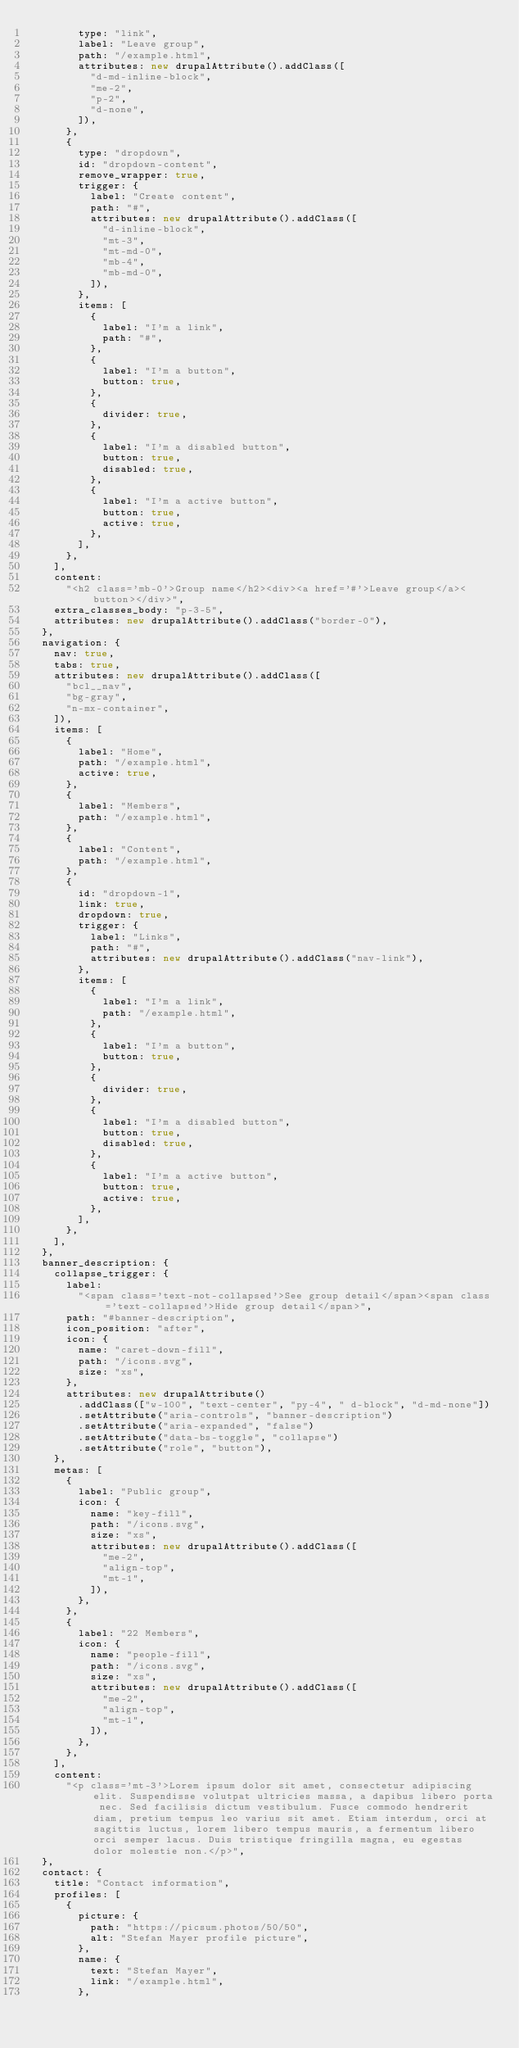Convert code to text. <code><loc_0><loc_0><loc_500><loc_500><_JavaScript_>        type: "link",
        label: "Leave group",
        path: "/example.html",
        attributes: new drupalAttribute().addClass([
          "d-md-inline-block",
          "me-2",
          "p-2",
          "d-none",
        ]),
      },
      {
        type: "dropdown",
        id: "dropdown-content",
        remove_wrapper: true,
        trigger: {
          label: "Create content",
          path: "#",
          attributes: new drupalAttribute().addClass([
            "d-inline-block",
            "mt-3",
            "mt-md-0",
            "mb-4",
            "mb-md-0",
          ]),
        },
        items: [
          {
            label: "I'm a link",
            path: "#",
          },
          {
            label: "I'm a button",
            button: true,
          },
          {
            divider: true,
          },
          {
            label: "I'm a disabled button",
            button: true,
            disabled: true,
          },
          {
            label: "I'm a active button",
            button: true,
            active: true,
          },
        ],
      },
    ],
    content:
      "<h2 class='mb-0'>Group name</h2><div><a href='#'>Leave group</a><button></div>",
    extra_classes_body: "p-3-5",
    attributes: new drupalAttribute().addClass("border-0"),
  },
  navigation: {
    nav: true,
    tabs: true,
    attributes: new drupalAttribute().addClass([
      "bcl__nav",
      "bg-gray",
      "n-mx-container",
    ]),
    items: [
      {
        label: "Home",
        path: "/example.html",
        active: true,
      },
      {
        label: "Members",
        path: "/example.html",
      },
      {
        label: "Content",
        path: "/example.html",
      },
      {
        id: "dropdown-1",
        link: true,
        dropdown: true,
        trigger: {
          label: "Links",
          path: "#",
          attributes: new drupalAttribute().addClass("nav-link"),
        },
        items: [
          {
            label: "I'm a link",
            path: "/example.html",
          },
          {
            label: "I'm a button",
            button: true,
          },
          {
            divider: true,
          },
          {
            label: "I'm a disabled button",
            button: true,
            disabled: true,
          },
          {
            label: "I'm a active button",
            button: true,
            active: true,
          },
        ],
      },
    ],
  },
  banner_description: {
    collapse_trigger: {
      label:
        "<span class='text-not-collapsed'>See group detail</span><span class='text-collapsed'>Hide group detail</span>",
      path: "#banner-description",
      icon_position: "after",
      icon: {
        name: "caret-down-fill",
        path: "/icons.svg",
        size: "xs",
      },
      attributes: new drupalAttribute()
        .addClass(["w-100", "text-center", "py-4", " d-block", "d-md-none"])
        .setAttribute("aria-controls", "banner-description")
        .setAttribute("aria-expanded", "false")
        .setAttribute("data-bs-toggle", "collapse")
        .setAttribute("role", "button"),
    },
    metas: [
      {
        label: "Public group",
        icon: {
          name: "key-fill",
          path: "/icons.svg",
          size: "xs",
          attributes: new drupalAttribute().addClass([
            "me-2",
            "align-top",
            "mt-1",
          ]),
        },
      },
      {
        label: "22 Members",
        icon: {
          name: "people-fill",
          path: "/icons.svg",
          size: "xs",
          attributes: new drupalAttribute().addClass([
            "me-2",
            "align-top",
            "mt-1",
          ]),
        },
      },
    ],
    content:
      "<p class='mt-3'>Lorem ipsum dolor sit amet, consectetur adipiscing elit. Suspendisse volutpat ultricies massa, a dapibus libero porta nec. Sed facilisis dictum vestibulum. Fusce commodo hendrerit diam, pretium tempus leo varius sit amet. Etiam interdum, orci at sagittis luctus, lorem libero tempus mauris, a fermentum libero orci semper lacus. Duis tristique fringilla magna, eu egestas dolor molestie non.</p>",
  },
  contact: {
    title: "Contact information",
    profiles: [
      {
        picture: {
          path: "https://picsum.photos/50/50",
          alt: "Stefan Mayer profile picture",
        },
        name: {
          text: "Stefan Mayer",
          link: "/example.html",
        },</code> 